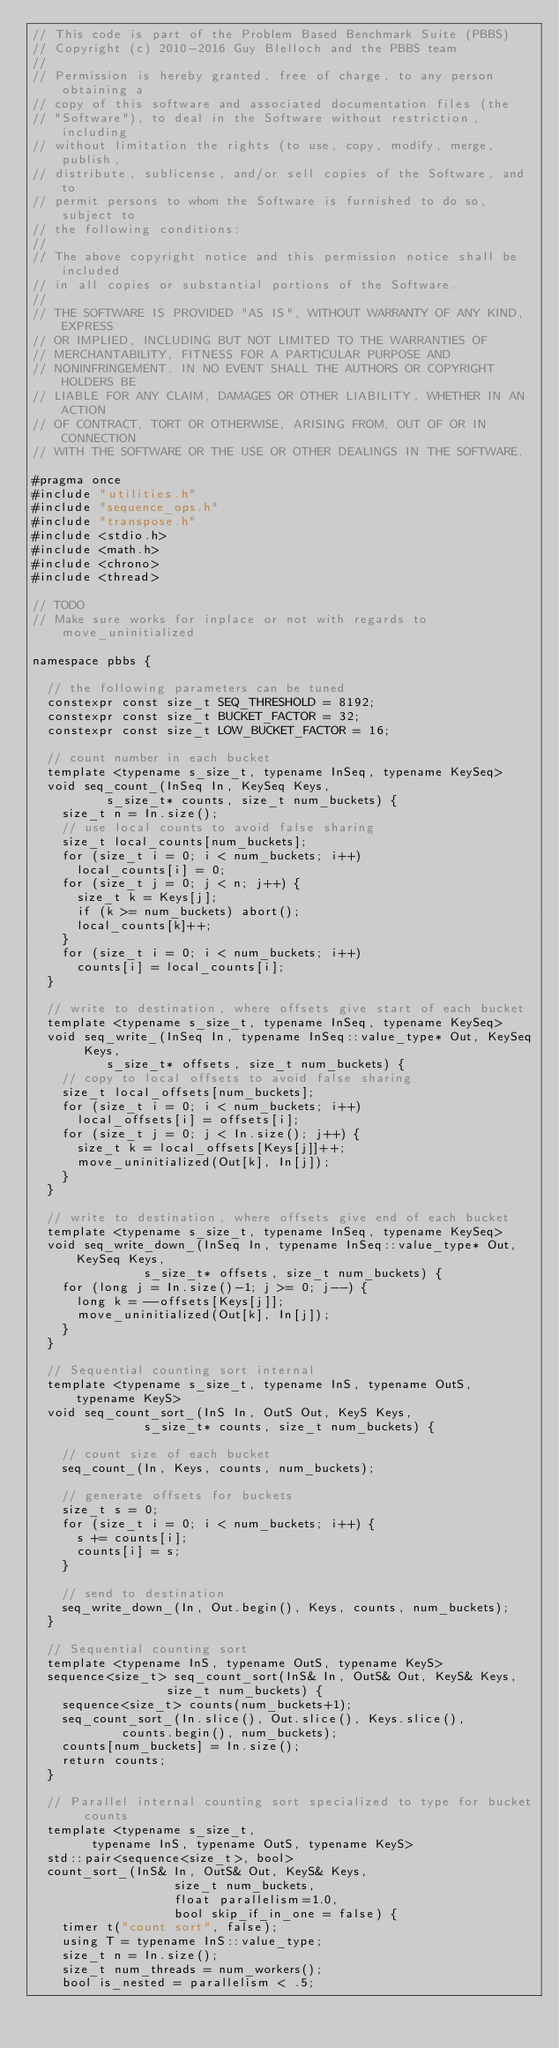<code> <loc_0><loc_0><loc_500><loc_500><_C_>// This code is part of the Problem Based Benchmark Suite (PBBS)
// Copyright (c) 2010-2016 Guy Blelloch and the PBBS team
//
// Permission is hereby granted, free of charge, to any person obtaining a
// copy of this software and associated documentation files (the
// "Software"), to deal in the Software without restriction, including
// without limitation the rights (to use, copy, modify, merge, publish,
// distribute, sublicense, and/or sell copies of the Software, and to
// permit persons to whom the Software is furnished to do so, subject to
// the following conditions:
//
// The above copyright notice and this permission notice shall be included
// in all copies or substantial portions of the Software.
//
// THE SOFTWARE IS PROVIDED "AS IS", WITHOUT WARRANTY OF ANY KIND, EXPRESS
// OR IMPLIED, INCLUDING BUT NOT LIMITED TO THE WARRANTIES OF
// MERCHANTABILITY, FITNESS FOR A PARTICULAR PURPOSE AND
// NONINFRINGEMENT. IN NO EVENT SHALL THE AUTHORS OR COPYRIGHT HOLDERS BE
// LIABLE FOR ANY CLAIM, DAMAGES OR OTHER LIABILITY, WHETHER IN AN ACTION
// OF CONTRACT, TORT OR OTHERWISE, ARISING FROM, OUT OF OR IN CONNECTION
// WITH THE SOFTWARE OR THE USE OR OTHER DEALINGS IN THE SOFTWARE.

#pragma once
#include "utilities.h"
#include "sequence_ops.h"
#include "transpose.h"
#include <stdio.h>
#include <math.h>
#include <chrono>
#include <thread>

// TODO
// Make sure works for inplace or not with regards to move_uninitialized

namespace pbbs {

  // the following parameters can be tuned
  constexpr const size_t SEQ_THRESHOLD = 8192;
  constexpr const size_t BUCKET_FACTOR = 32;
  constexpr const size_t LOW_BUCKET_FACTOR = 16;

  // count number in each bucket
  template <typename s_size_t, typename InSeq, typename KeySeq>
  void seq_count_(InSeq In, KeySeq Keys,
		  s_size_t* counts, size_t num_buckets) {
    size_t n = In.size();
    // use local counts to avoid false sharing
    size_t local_counts[num_buckets];
    for (size_t i = 0; i < num_buckets; i++)
      local_counts[i] = 0;
    for (size_t j = 0; j < n; j++) {
      size_t k = Keys[j];
      if (k >= num_buckets) abort();
      local_counts[k]++;
    }
    for (size_t i = 0; i < num_buckets; i++)
      counts[i] = local_counts[i];
  }

  // write to destination, where offsets give start of each bucket
  template <typename s_size_t, typename InSeq, typename KeySeq>
  void seq_write_(InSeq In, typename InSeq::value_type* Out, KeySeq Keys,
		  s_size_t* offsets, size_t num_buckets) {
    // copy to local offsets to avoid false sharing
    size_t local_offsets[num_buckets];
    for (size_t i = 0; i < num_buckets; i++)
      local_offsets[i] = offsets[i];
    for (size_t j = 0; j < In.size(); j++) {
      size_t k = local_offsets[Keys[j]]++;
      move_uninitialized(Out[k], In[j]);
    }
  }

  // write to destination, where offsets give end of each bucket
  template <typename s_size_t, typename InSeq, typename KeySeq>
  void seq_write_down_(InSeq In, typename InSeq::value_type* Out, KeySeq Keys,
		       s_size_t* offsets, size_t num_buckets) {
    for (long j = In.size()-1; j >= 0; j--) {
      long k = --offsets[Keys[j]];
      move_uninitialized(Out[k], In[j]);
    }
  }

  // Sequential counting sort internal
  template <typename s_size_t, typename InS, typename OutS, typename KeyS>
  void seq_count_sort_(InS In, OutS Out, KeyS Keys,
		       s_size_t* counts, size_t num_buckets) {

    // count size of each bucket
    seq_count_(In, Keys, counts, num_buckets);

    // generate offsets for buckets
    size_t s = 0;
    for (size_t i = 0; i < num_buckets; i++) {
      s += counts[i];
      counts[i] = s;
    }

    // send to destination
    seq_write_down_(In, Out.begin(), Keys, counts, num_buckets);
  }

  // Sequential counting sort
  template <typename InS, typename OutS, typename KeyS>
  sequence<size_t> seq_count_sort(InS& In, OutS& Out, KeyS& Keys,
				  size_t num_buckets) {
    sequence<size_t> counts(num_buckets+1);
    seq_count_sort_(In.slice(), Out.slice(), Keys.slice(),
		    counts.begin(), num_buckets);
    counts[num_buckets] = In.size();
    return counts;
  }

  // Parallel internal counting sort specialized to type for bucket counts
  template <typename s_size_t, 
	    typename InS, typename OutS, typename KeyS>
  std::pair<sequence<size_t>, bool>
  count_sort_(InS& In, OutS& Out, KeyS& Keys,
			       size_t num_buckets,
			       float parallelism=1.0,
			       bool skip_if_in_one = false) {
    timer t("count sort", false);
    using T = typename InS::value_type;
    size_t n = In.size();
    size_t num_threads = num_workers();
    bool is_nested = parallelism < .5;
</code> 